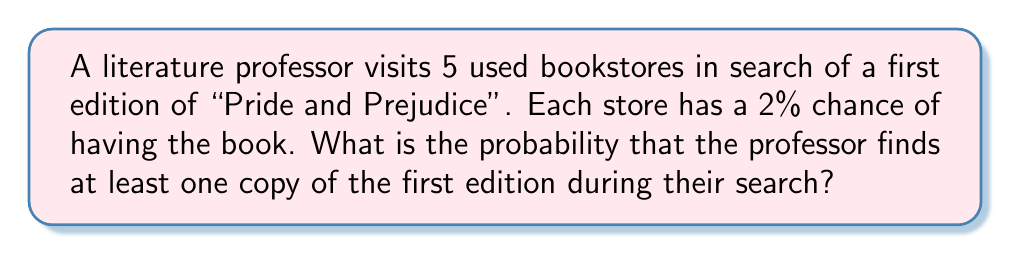Teach me how to tackle this problem. Let's approach this step-by-step:

1) First, let's calculate the probability of not finding the book in a single store:
   $P(\text{not finding in one store}) = 1 - 0.02 = 0.98$

2) Now, to not find the book in all 5 stores, this event must occur 5 times independently:
   $P(\text{not finding in any store}) = 0.98^5$

3) We can calculate this:
   $0.98^5 \approx 0.9039$

4) The probability of finding at least one copy is the complement of not finding any:
   $P(\text{finding at least one}) = 1 - P(\text{not finding in any store})$

5) Therefore:
   $P(\text{finding at least one}) = 1 - 0.9039 = 0.0961$

6) Convert to percentage:
   $0.0961 \times 100\% = 9.61\%$

Thus, the probability of finding at least one first edition of "Pride and Prejudice" is approximately 9.61%.
Answer: 9.61% 